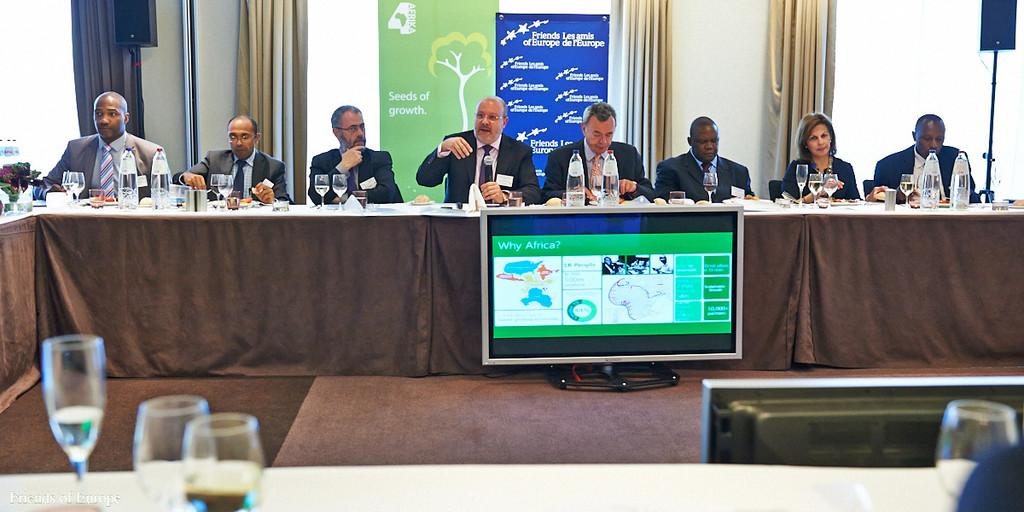<image>
Provide a brief description of the given image. A seated group of panelist sponsored by the Friends of Europe. 